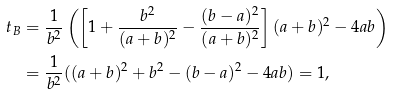<formula> <loc_0><loc_0><loc_500><loc_500>t _ { B } & = \frac { 1 } { b ^ { 2 } } \left ( \left [ 1 + \frac { b ^ { 2 } } { ( a + b ) ^ { 2 } } - \frac { ( b - a ) ^ { 2 } } { ( a + b ) ^ { 2 } } \right ] ( a + b ) ^ { 2 } - 4 a b \right ) \\ & = \frac { 1 } { b ^ { 2 } } ( ( a + b ) ^ { 2 } + b ^ { 2 } - ( b - a ) ^ { 2 } - 4 a b ) = 1 ,</formula> 